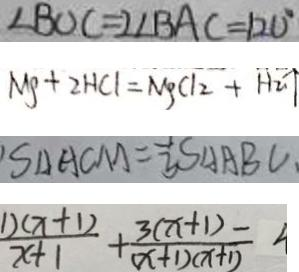Convert formula to latex. <formula><loc_0><loc_0><loc_500><loc_500>\angle B O C = 2 \angle B A C = 1 2 0 ^ { \circ } 
 M g + 2 H C l = M g C l _ { 2 } + H _ { 2 } \uparrow 
 S _ { \Delta A C M } = \frac { 1 } { 3 } S _ { \Delta A B C } . 
 \frac { 1 ) ( x + 1 ) } { x + 1 } + \frac { 3 ( x + 1 ) } { ( x + 1 ) ( x + 1 ) } =</formula> 